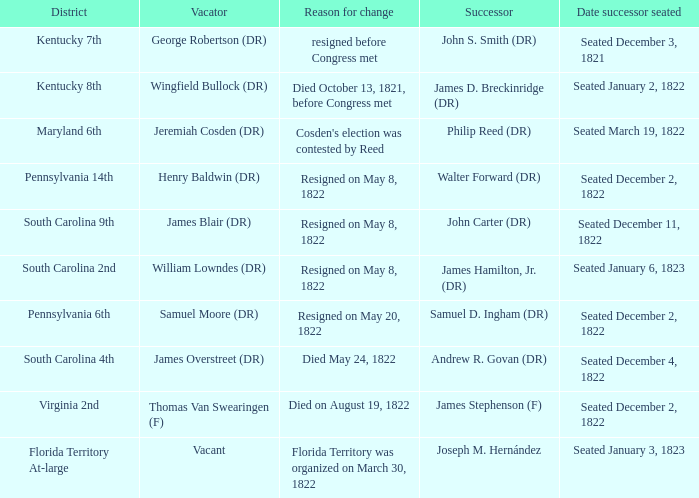What is the reason for change when maryland 6th is the district?  Cosden's election was contested by Reed. 